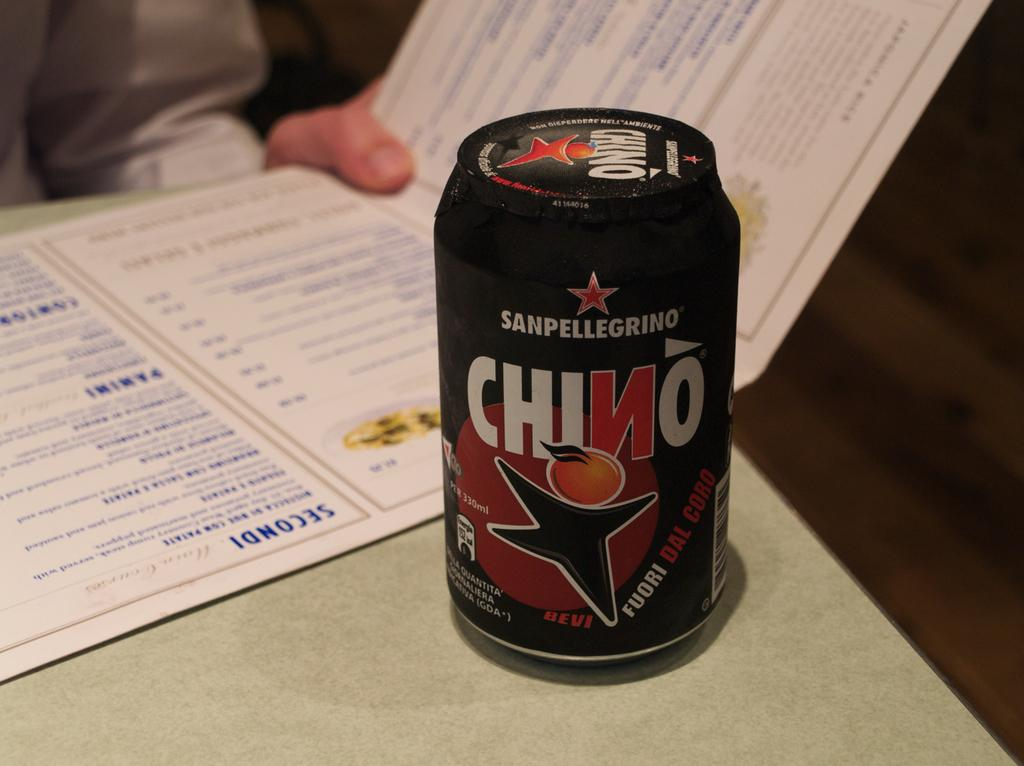<image>
Offer a succinct explanation of the picture presented. SECONDI is a word ontop of the menue being read. 